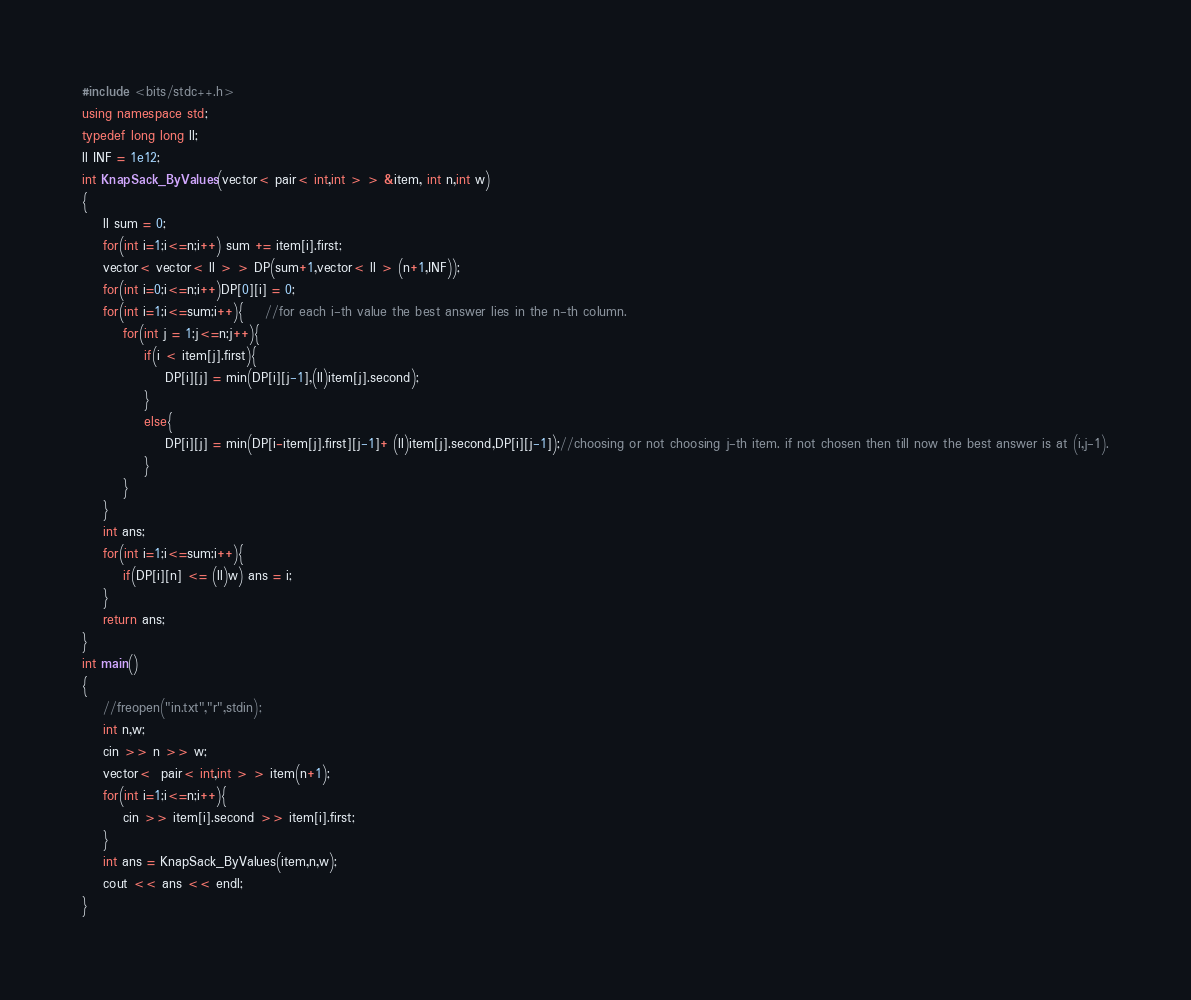Convert code to text. <code><loc_0><loc_0><loc_500><loc_500><_C++_>#include <bits/stdc++.h>
using namespace std;
typedef long long ll;
ll INF = 1e12;
int KnapSack_ByValues(vector< pair< int,int > > &item, int n,int w)
{
    ll sum = 0;
    for(int i=1;i<=n;i++) sum += item[i].first;
    vector< vector< ll > > DP(sum+1,vector< ll > (n+1,INF));
    for(int i=0;i<=n;i++)DP[0][i] = 0;
    for(int i=1;i<=sum;i++){    //for each i-th value the best answer lies in the n-th column.
        for(int j = 1;j<=n;j++){
            if(i < item[j].first){
                DP[i][j] = min(DP[i][j-1],(ll)item[j].second);
            }
            else{
                DP[i][j] = min(DP[i-item[j].first][j-1]+ (ll)item[j].second,DP[i][j-1]);//choosing or not choosing j-th item. if not chosen then till now the best answer is at (i,j-1).
            }
        }
    }
    int ans;
    for(int i=1;i<=sum;i++){
        if(DP[i][n] <= (ll)w) ans = i;
    }
    return ans;
}
int main()
{
    //freopen("in.txt","r",stdin);
    int n,w;
    cin >> n >> w;
    vector<  pair< int,int > > item(n+1);
    for(int i=1;i<=n;i++){
        cin >> item[i].second >> item[i].first;
    }
    int ans = KnapSack_ByValues(item,n,w);
    cout << ans << endl;
}</code> 